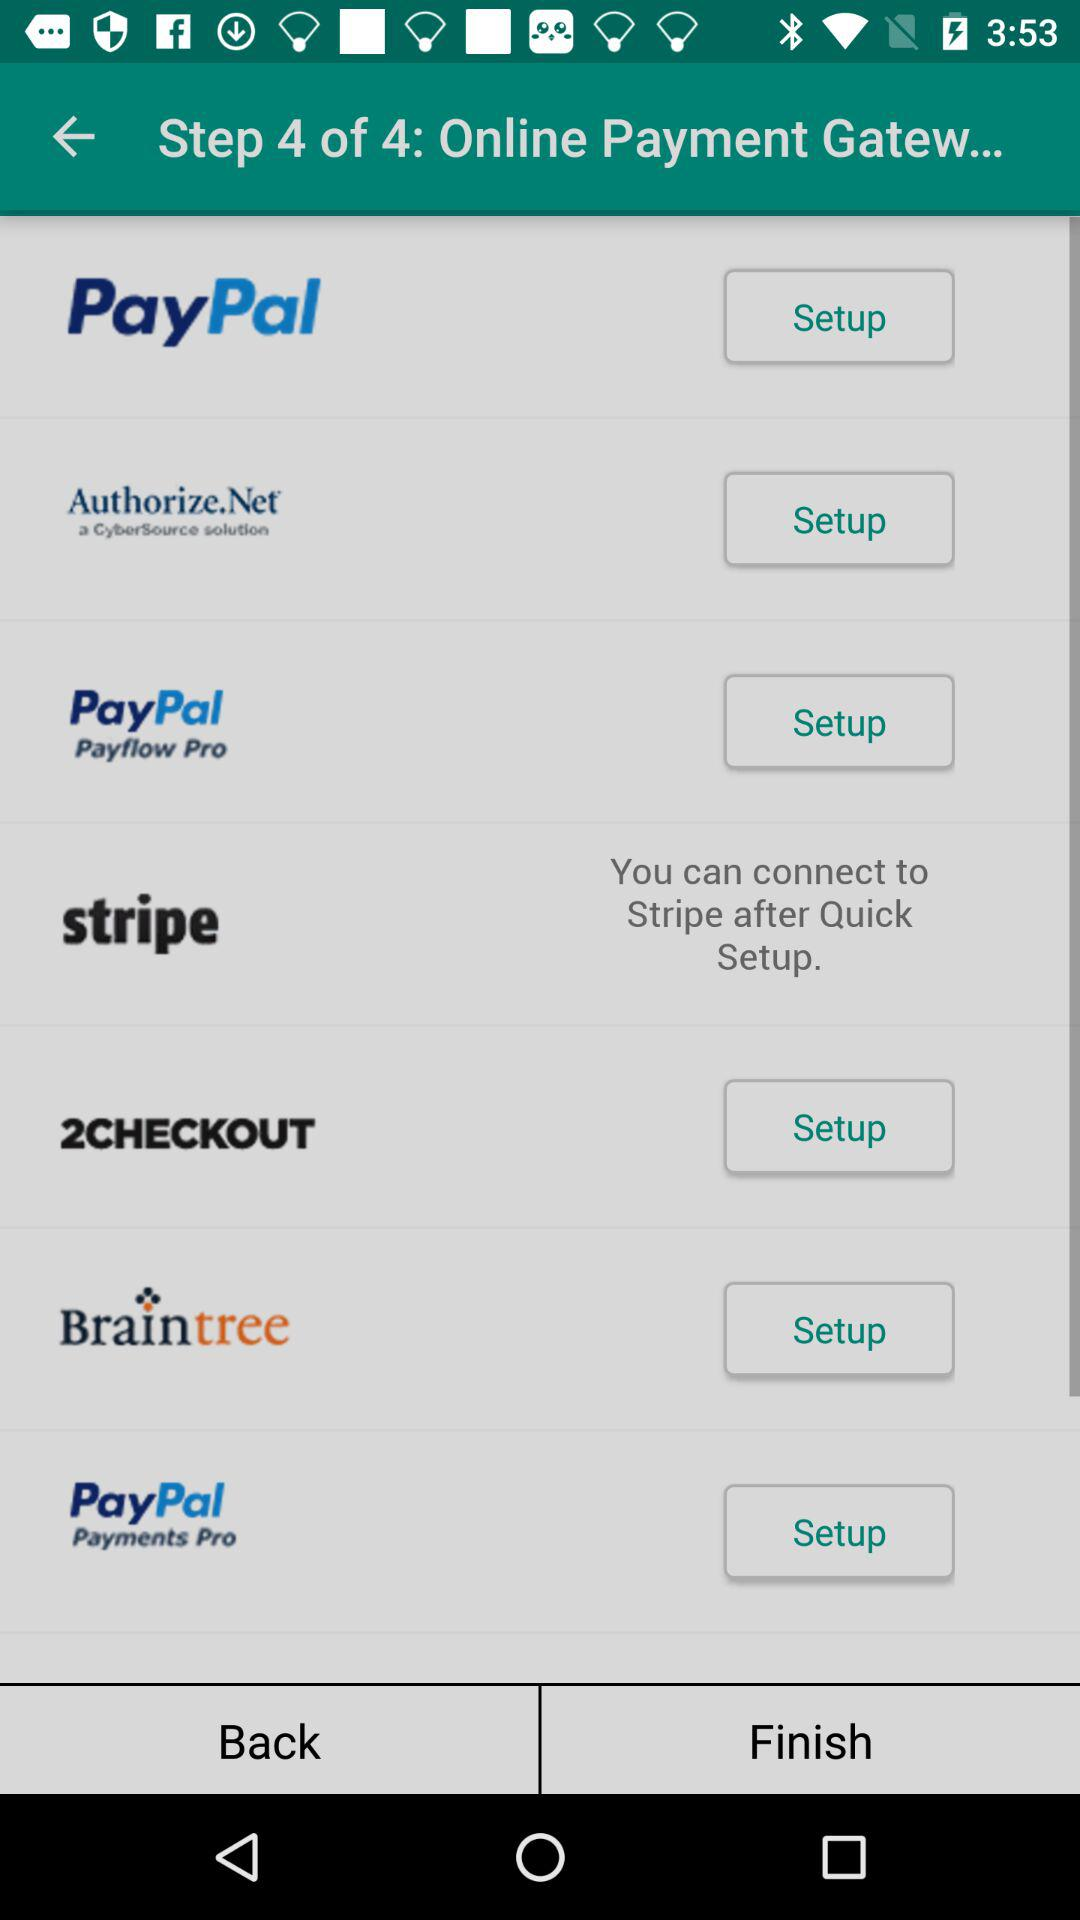How many steps in total are there? There are 4 steps in total. 